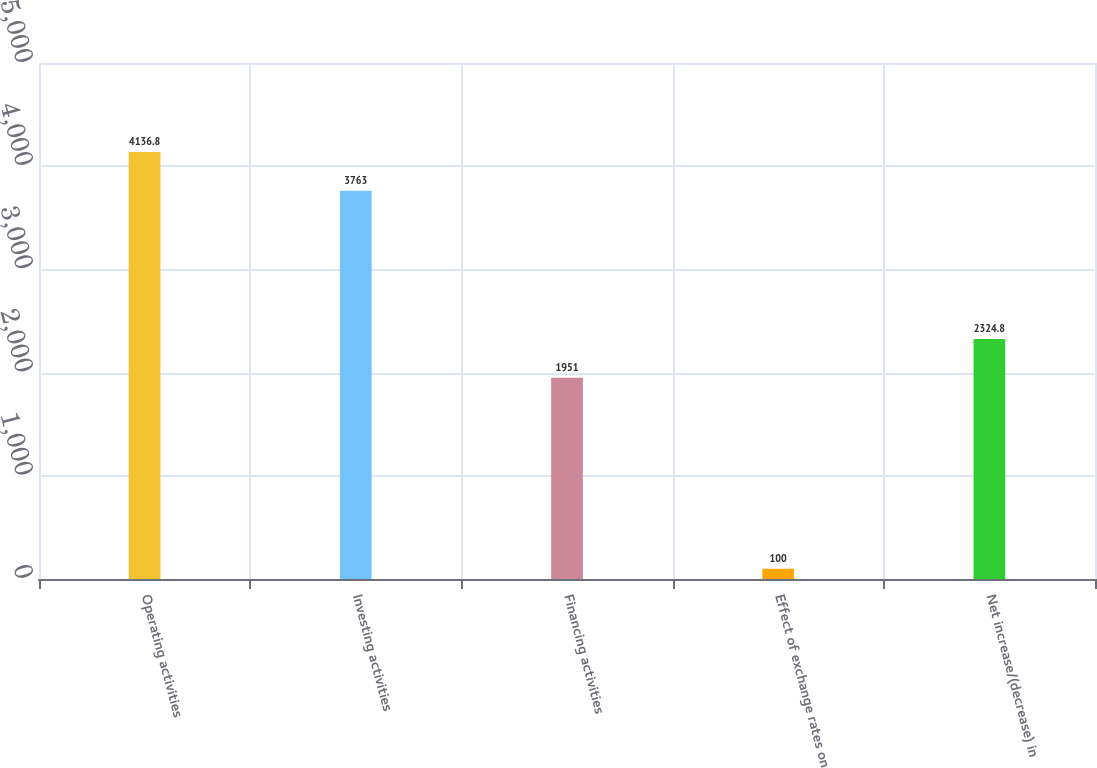<chart> <loc_0><loc_0><loc_500><loc_500><bar_chart><fcel>Operating activities<fcel>Investing activities<fcel>Financing activities<fcel>Effect of exchange rates on<fcel>Net increase/(decrease) in<nl><fcel>4136.8<fcel>3763<fcel>1951<fcel>100<fcel>2324.8<nl></chart> 